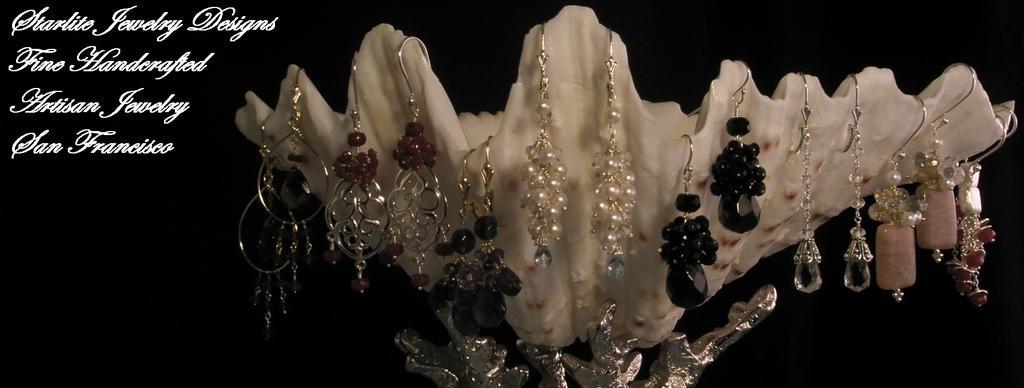In one or two sentences, can you explain what this image depicts? In this picture I can see pairs of earrings hanging on the edges of a shell, there is dark background and there are words on the image. 